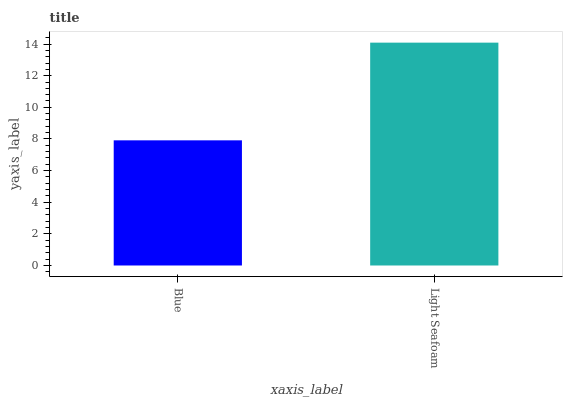Is Blue the minimum?
Answer yes or no. Yes. Is Light Seafoam the maximum?
Answer yes or no. Yes. Is Light Seafoam the minimum?
Answer yes or no. No. Is Light Seafoam greater than Blue?
Answer yes or no. Yes. Is Blue less than Light Seafoam?
Answer yes or no. Yes. Is Blue greater than Light Seafoam?
Answer yes or no. No. Is Light Seafoam less than Blue?
Answer yes or no. No. Is Light Seafoam the high median?
Answer yes or no. Yes. Is Blue the low median?
Answer yes or no. Yes. Is Blue the high median?
Answer yes or no. No. Is Light Seafoam the low median?
Answer yes or no. No. 